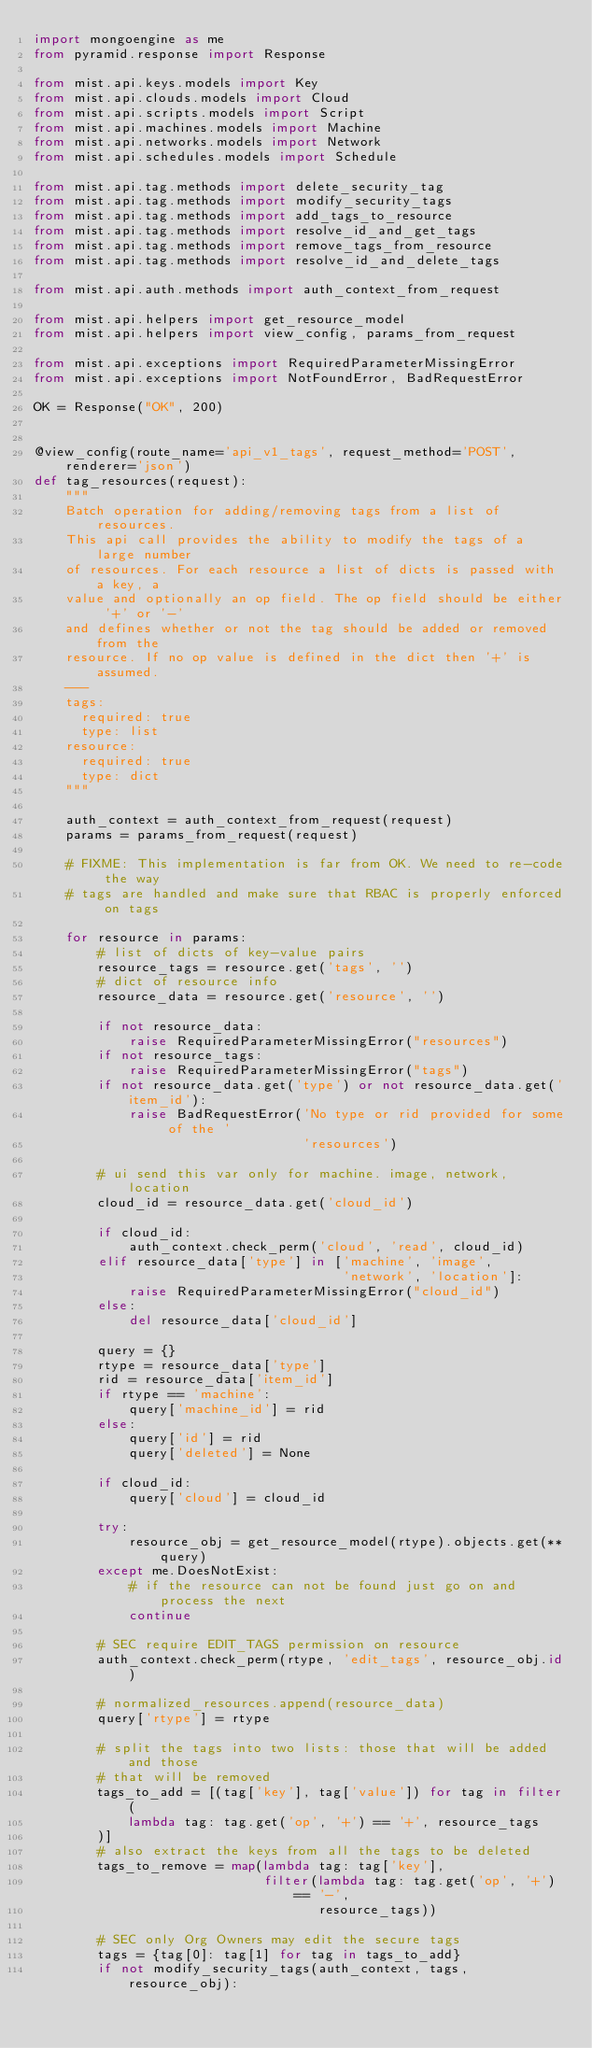Convert code to text. <code><loc_0><loc_0><loc_500><loc_500><_Python_>import mongoengine as me
from pyramid.response import Response

from mist.api.keys.models import Key
from mist.api.clouds.models import Cloud
from mist.api.scripts.models import Script
from mist.api.machines.models import Machine
from mist.api.networks.models import Network
from mist.api.schedules.models import Schedule

from mist.api.tag.methods import delete_security_tag
from mist.api.tag.methods import modify_security_tags
from mist.api.tag.methods import add_tags_to_resource
from mist.api.tag.methods import resolve_id_and_get_tags
from mist.api.tag.methods import remove_tags_from_resource
from mist.api.tag.methods import resolve_id_and_delete_tags

from mist.api.auth.methods import auth_context_from_request

from mist.api.helpers import get_resource_model
from mist.api.helpers import view_config, params_from_request

from mist.api.exceptions import RequiredParameterMissingError
from mist.api.exceptions import NotFoundError, BadRequestError

OK = Response("OK", 200)


@view_config(route_name='api_v1_tags', request_method='POST', renderer='json')
def tag_resources(request):
    """
    Batch operation for adding/removing tags from a list of resources.
    This api call provides the ability to modify the tags of a large number
    of resources. For each resource a list of dicts is passed with a key, a
    value and optionally an op field. The op field should be either '+' or '-'
    and defines whether or not the tag should be added or removed from the
    resource. If no op value is defined in the dict then '+' is assumed.
    ---
    tags:
      required: true
      type: list
    resource:
      required: true
      type: dict
    """

    auth_context = auth_context_from_request(request)
    params = params_from_request(request)

    # FIXME: This implementation is far from OK. We need to re-code the way
    # tags are handled and make sure that RBAC is properly enforced on tags

    for resource in params:
        # list of dicts of key-value pairs
        resource_tags = resource.get('tags', '')
        # dict of resource info
        resource_data = resource.get('resource', '')

        if not resource_data:
            raise RequiredParameterMissingError("resources")
        if not resource_tags:
            raise RequiredParameterMissingError("tags")
        if not resource_data.get('type') or not resource_data.get('item_id'):
            raise BadRequestError('No type or rid provided for some of the '
                                  'resources')

        # ui send this var only for machine. image, network, location
        cloud_id = resource_data.get('cloud_id')

        if cloud_id:
            auth_context.check_perm('cloud', 'read', cloud_id)
        elif resource_data['type'] in ['machine', 'image',
                                       'network', 'location']:
            raise RequiredParameterMissingError("cloud_id")
        else:
            del resource_data['cloud_id']

        query = {}
        rtype = resource_data['type']
        rid = resource_data['item_id']
        if rtype == 'machine':
            query['machine_id'] = rid
        else:
            query['id'] = rid
            query['deleted'] = None

        if cloud_id:
            query['cloud'] = cloud_id

        try:
            resource_obj = get_resource_model(rtype).objects.get(**query)
        except me.DoesNotExist:
            # if the resource can not be found just go on and process the next
            continue

        # SEC require EDIT_TAGS permission on resource
        auth_context.check_perm(rtype, 'edit_tags', resource_obj.id)

        # normalized_resources.append(resource_data)
        query['rtype'] = rtype

        # split the tags into two lists: those that will be added and those
        # that will be removed
        tags_to_add = [(tag['key'], tag['value']) for tag in filter(
            lambda tag: tag.get('op', '+') == '+', resource_tags
        )]
        # also extract the keys from all the tags to be deleted
        tags_to_remove = map(lambda tag: tag['key'],
                             filter(lambda tag: tag.get('op', '+') == '-',
                                    resource_tags))

        # SEC only Org Owners may edit the secure tags
        tags = {tag[0]: tag[1] for tag in tags_to_add}
        if not modify_security_tags(auth_context, tags, resource_obj):</code> 